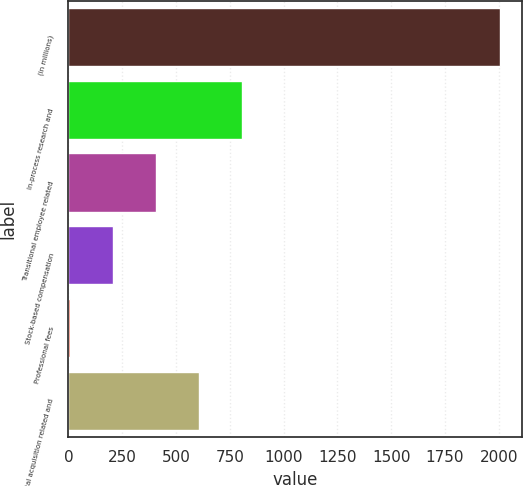Convert chart. <chart><loc_0><loc_0><loc_500><loc_500><bar_chart><fcel>(in millions)<fcel>In-process research and<fcel>Transitional employee related<fcel>Stock-based compensation<fcel>Professional fees<fcel>Total acquisition related and<nl><fcel>2007<fcel>807.6<fcel>407.8<fcel>207.9<fcel>8<fcel>607.7<nl></chart> 